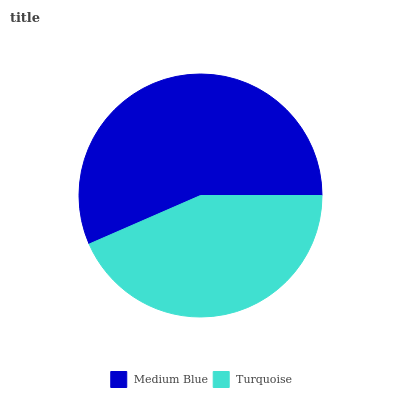Is Turquoise the minimum?
Answer yes or no. Yes. Is Medium Blue the maximum?
Answer yes or no. Yes. Is Turquoise the maximum?
Answer yes or no. No. Is Medium Blue greater than Turquoise?
Answer yes or no. Yes. Is Turquoise less than Medium Blue?
Answer yes or no. Yes. Is Turquoise greater than Medium Blue?
Answer yes or no. No. Is Medium Blue less than Turquoise?
Answer yes or no. No. Is Medium Blue the high median?
Answer yes or no. Yes. Is Turquoise the low median?
Answer yes or no. Yes. Is Turquoise the high median?
Answer yes or no. No. Is Medium Blue the low median?
Answer yes or no. No. 